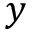<formula> <loc_0><loc_0><loc_500><loc_500>y</formula> 